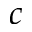Convert formula to latex. <formula><loc_0><loc_0><loc_500><loc_500>c</formula> 